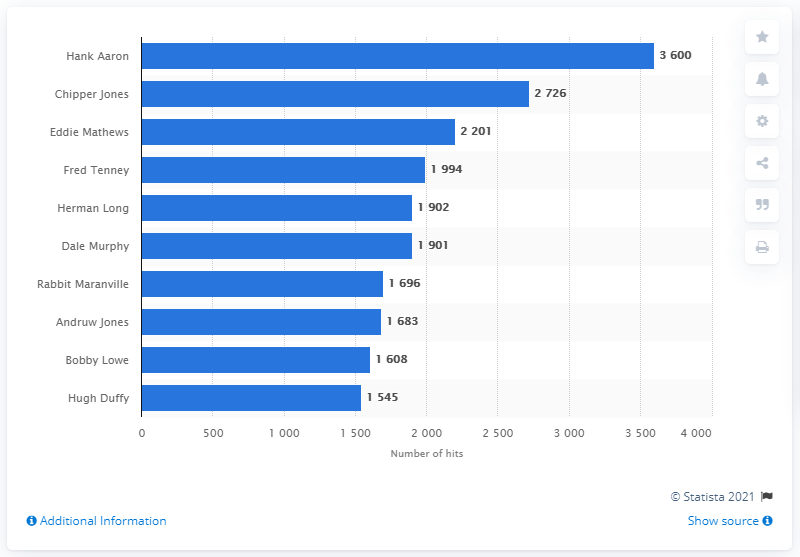Specify some key components in this picture. Hank Aaron holds the record for the most hits in the history of the Atlanta Braves franchise. 